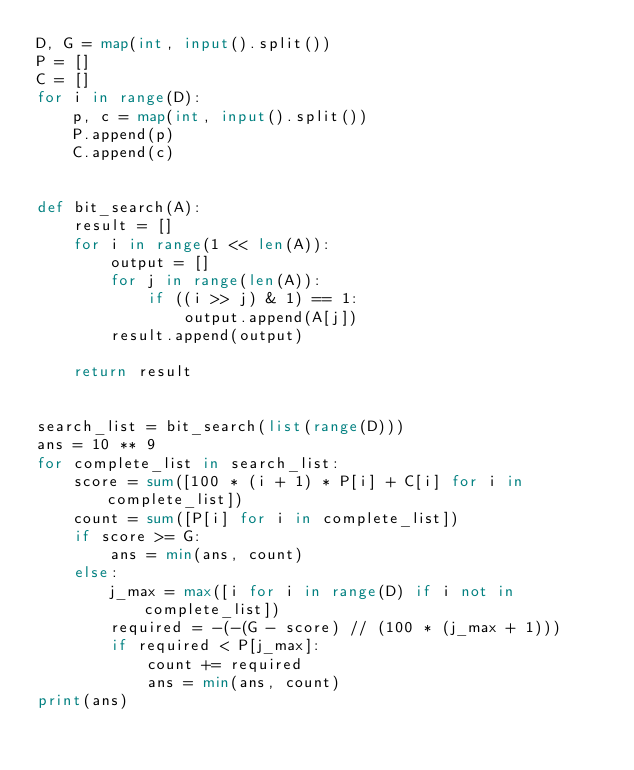Convert code to text. <code><loc_0><loc_0><loc_500><loc_500><_Python_>D, G = map(int, input().split())
P = []
C = []
for i in range(D):
    p, c = map(int, input().split())
    P.append(p)
    C.append(c)


def bit_search(A):
    result = []
    for i in range(1 << len(A)):
        output = []
        for j in range(len(A)):
            if ((i >> j) & 1) == 1:
                output.append(A[j])
        result.append(output)

    return result


search_list = bit_search(list(range(D)))
ans = 10 ** 9
for complete_list in search_list:
    score = sum([100 * (i + 1) * P[i] + C[i] for i in complete_list])
    count = sum([P[i] for i in complete_list])
    if score >= G:
        ans = min(ans, count)
    else:
        j_max = max([i for i in range(D) if i not in complete_list])
        required = -(-(G - score) // (100 * (j_max + 1)))
        if required < P[j_max]:
            count += required
            ans = min(ans, count)
print(ans)
</code> 